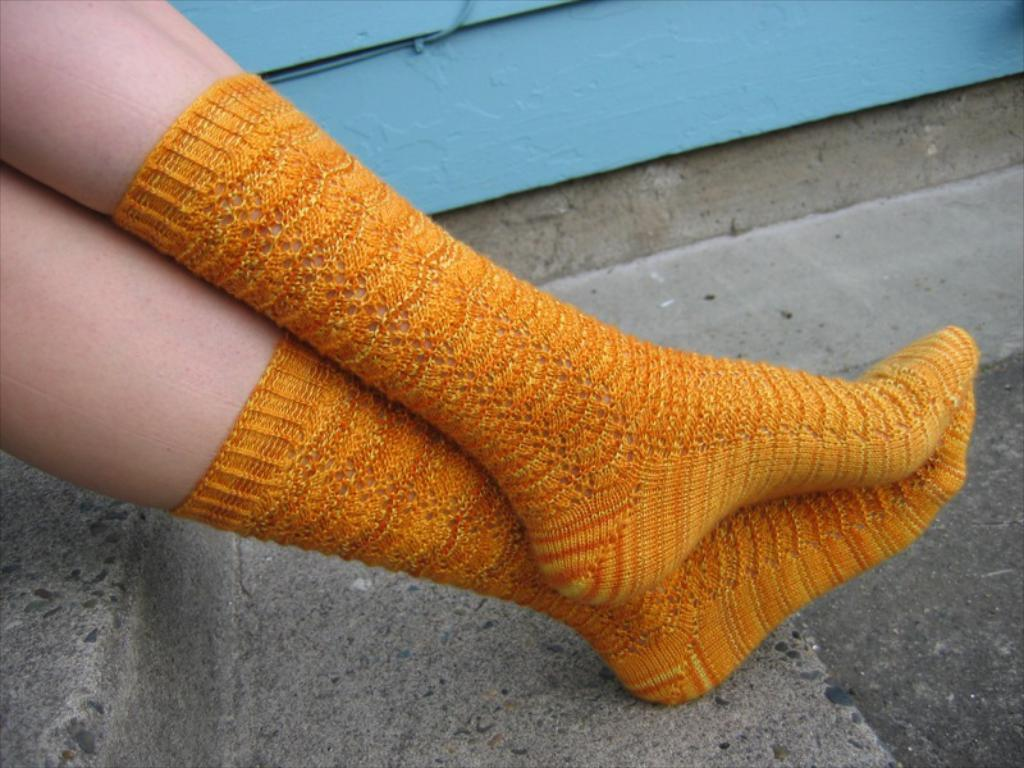Who or what is present in the image? There is a person in the image. What type of clothing is the person wearing on their feet? The person is wearing socks. What can be seen in the background of the image? There is a wall in the image. What is visible at the bottom of the image? There is a road at the bottom of the image. How does the fog affect the person's visibility in the image? There is no fog present in the image, so it does not affect the person's visibility. 